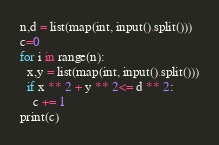<code> <loc_0><loc_0><loc_500><loc_500><_Python_>n,d = list(map(int, input().split()))
c=0
for i in range(n):
  x,y = list(map(int, input().split()))
  if x ** 2 + y ** 2<= d ** 2:
    c += 1
print(c)</code> 